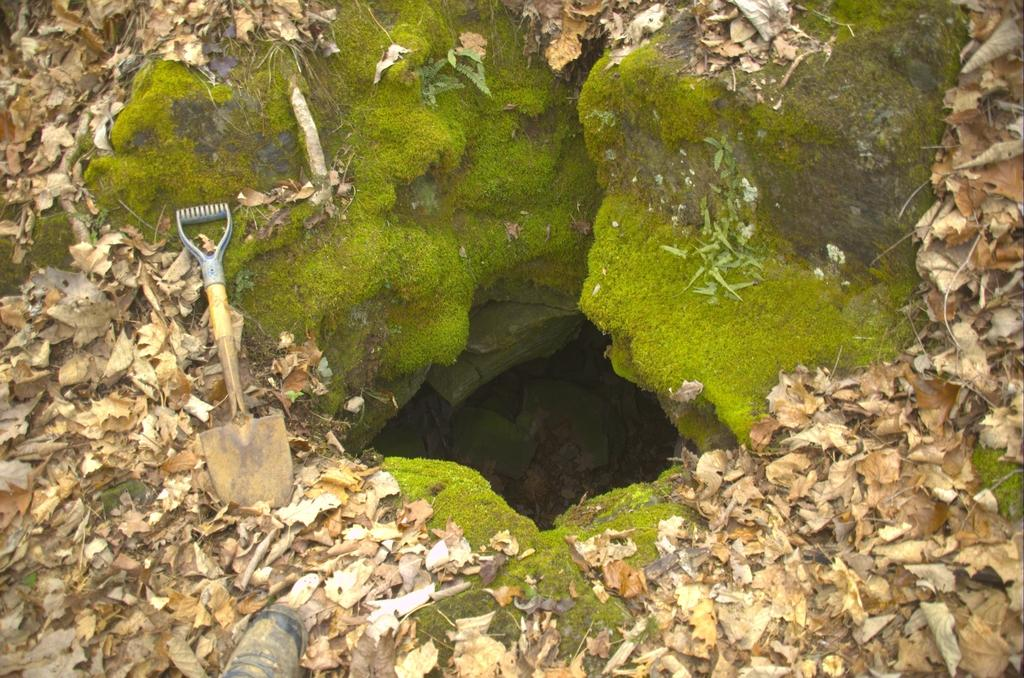What is the main feature in the image? There is a pit in the image. What can be seen beside the pit? There is a digging tool beside the pit. What type of natural growth is present in the image? Fungus is present in the image. What type of plant material can be seen in the image? Leaves are visible in the image. How many pets are visible in the image? There are no pets present in the image. What type of stem can be seen supporting the duck in the image? There is no duck present in the image, and therefore no stem supporting it. 